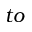<formula> <loc_0><loc_0><loc_500><loc_500>t o</formula> 